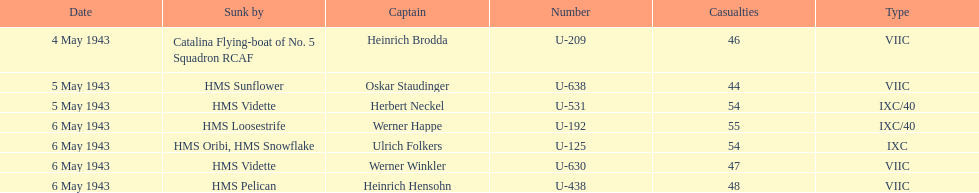Which ship sunk the most u-boats HMS Vidette. 